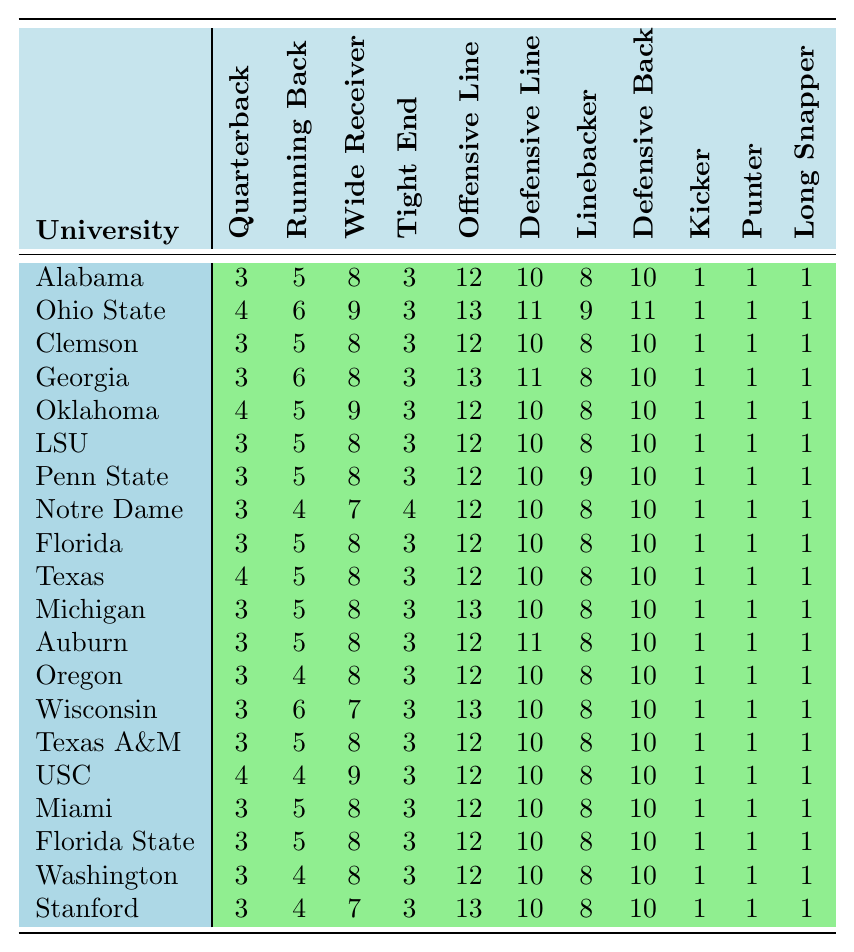What is the maximum number of tight ends offered by any university? Looking through the Tight End column, I see the highest value is 4, which occurs for Notre Dame.
Answer: 4 Which university has the lowest number of running backs? By reviewing the Running Back column, I find that both Notre Dame and Florida State have the lowest count of 4.
Answer: 4 How many more defensive backs does Ohio State have compared to Miami? Ohio State has 11 defensive backs, while Miami has 10. The difference is 11 - 10 = 1.
Answer: 1 What is the total number of quarterbacks across all universities? Adding the values of the Quarterback column gives the total: 3+4+3+3+4+3+3+3+3+4+3+3+3+3+3+4+3+3+3+3 =  63.
Answer: 63 Are there more wide receivers or linebackers in total across all universities? The total for wide receivers is 8 + 9 + 8 + 8 + 9 + 8 + 8 + 7 + 8 + 8 + 8 + 8 + 8 + 7 + 8 + 9 + 8 + 8 + 8 + 7 = 163, while the total for linebackers is 8 * 20 = 160. There are more wide receivers.
Answer: Yes What is the average number of offensive linemen among the top 20 universities? The total for offensive linemen is: 12 + 13 + 12 + 13 + 12 + 12 + 12 + 12 + 12 + 12 + 13 + 12 + 12 + 13 + 12 + 12 + 12 + 12 + 12 + 13 =  244. Dividing by 20 universities gives an average of 244/20 = 12.2.
Answer: 12.2 Which position has the highest total scholarships and what is that amount? Sum the columns: QB 63, RB 98, WR 163, TE 52, OL 241, DL 200, LB 160, DB 200, K 20, P 20, LS 20. Hence, Offensive Line has the highest amount (241).
Answer: Offensive Line, 241 How many more linebackers does Penn State have compared to Florida State? Penn State has 9 linebackers and Florida State has 8. The difference is 9 - 8 = 1.
Answer: 1 Which university has the same number of kicking specialists (kickers, punters, long snappers) as Texas A&M? Since all universities have 1 kicker, 1 punter, and 1 long snapper, every university has the same number, including Texas A&M.
Answer: All universities What is the total number of players for the university with the most defensive linemen? Ohio State has the most with 11 defensive linemen. Adding all positions gives: 4 + 6 + 9 + 3 + 13 + 11 + 9 + 11 + 1 + 1 + 1 = 73.
Answer: 73 